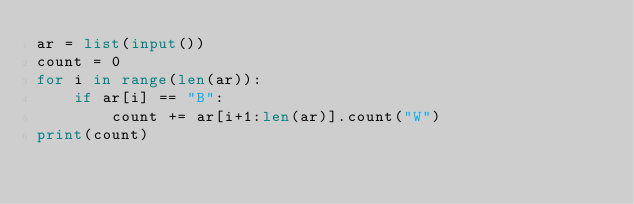<code> <loc_0><loc_0><loc_500><loc_500><_Python_>ar = list(input())
count = 0
for i in range(len(ar)):
    if ar[i] == "B":
        count += ar[i+1:len(ar)].count("W")
print(count)</code> 